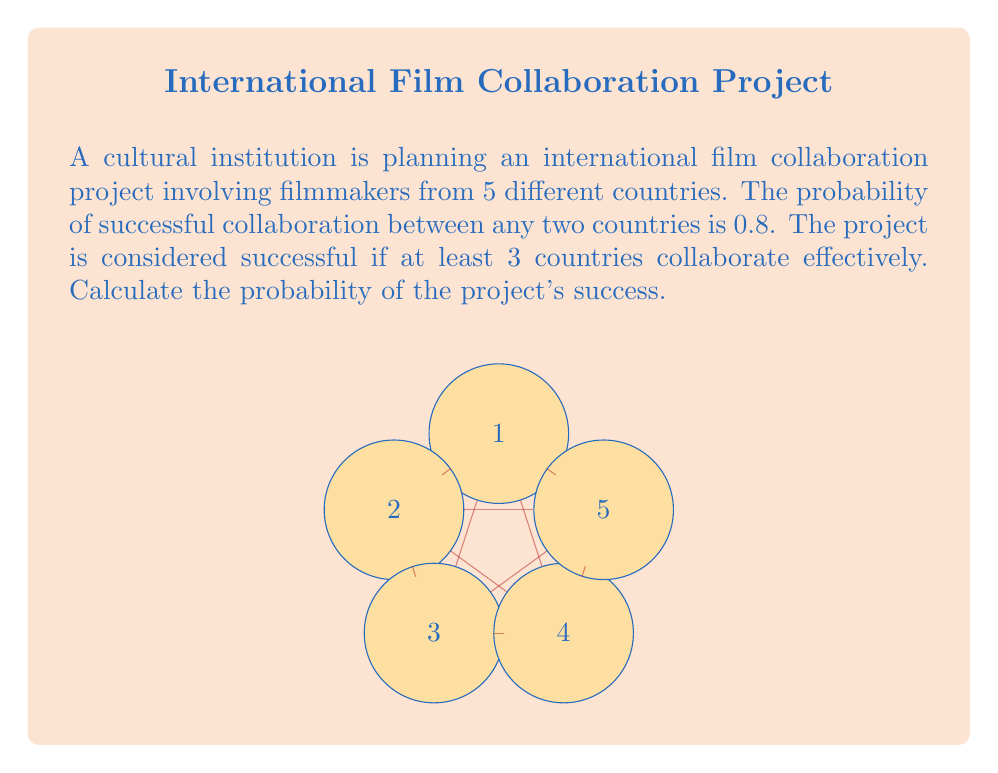Could you help me with this problem? Let's approach this step-by-step:

1) First, we need to calculate the probability of a single country not collaborating effectively. If the probability of successful collaboration is 0.8, then:

   $P(\text{not collaborating}) = 1 - 0.8 = 0.2$

2) Now, we can use the binomial probability distribution to calculate the probability of exactly $k$ countries not collaborating:

   $P(X = k) = \binom{5}{k} (0.2)^k (0.8)^{5-k}$

3) We want at least 3 countries to collaborate, which means we can have 0, 1, or 2 countries not collaborating. So we need to sum these probabilities:

   $P(\text{success}) = P(X = 0) + P(X = 1) + P(X = 2)$

4) Let's calculate each term:

   $P(X = 0) = \binom{5}{0} (0.2)^0 (0.8)^5 = 1 \cdot 1 \cdot 0.32768 = 0.32768$

   $P(X = 1) = \binom{5}{1} (0.2)^1 (0.8)^4 = 5 \cdot 0.2 \cdot 0.4096 = 0.4096$

   $P(X = 2) = \binom{5}{2} (0.2)^2 (0.8)^3 = 10 \cdot 0.04 \cdot 0.512 = 0.2048$

5) Now, we sum these probabilities:

   $P(\text{success}) = 0.32768 + 0.4096 + 0.2048 = 0.94208$

Therefore, the probability of the project's success is approximately 0.94208 or 94.208%.
Answer: 0.94208 